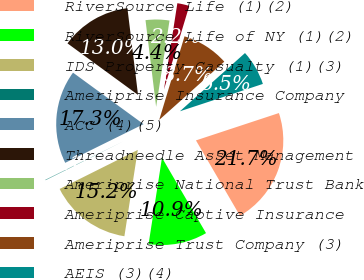Convert chart. <chart><loc_0><loc_0><loc_500><loc_500><pie_chart><fcel>RiverSource Life (1)(2)<fcel>RiverSource Life of NY (1)(2)<fcel>IDS Property Casualty (1)(3)<fcel>Ameriprise Insurance Company<fcel>ACC (4)(5)<fcel>Threadneedle Asset Management<fcel>Ameriprise National Trust Bank<fcel>Ameriprise Captive Insurance<fcel>Ameriprise Trust Company (3)<fcel>AEIS (3)(4)<nl><fcel>21.66%<fcel>10.86%<fcel>15.18%<fcel>0.07%<fcel>17.34%<fcel>13.02%<fcel>4.39%<fcel>2.23%<fcel>8.7%<fcel>6.55%<nl></chart> 